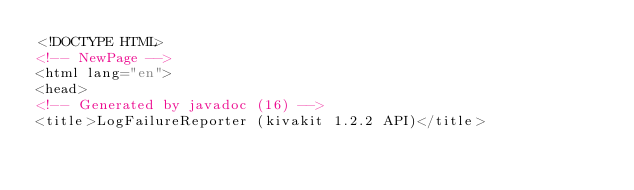Convert code to text. <code><loc_0><loc_0><loc_500><loc_500><_HTML_><!DOCTYPE HTML>
<!-- NewPage -->
<html lang="en">
<head>
<!-- Generated by javadoc (16) -->
<title>LogFailureReporter (kivakit 1.2.2 API)</title></code> 